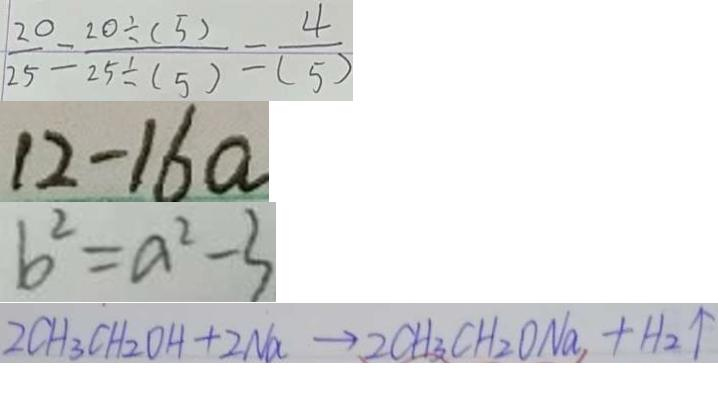<formula> <loc_0><loc_0><loc_500><loc_500>\frac { 2 0 } { 2 5 } = \frac { 2 0 \div ( 5 ) } { 2 5 \div ( 5 ) } = \frac { 4 } { ( 5 ) } 
 1 2 - 1 6 a 
 b ^ { 2 } = a ^ { 2 } - 3 
 2 C H _ { 3 } C H _ { 2 } O H + 2 N a \rightarrow 2 C H _ { 3 } C H _ { 2 } O N a _ { 1 } + H _ { 2 } \uparrow</formula> 